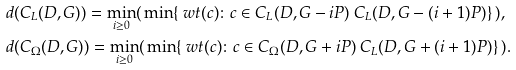Convert formula to latex. <formula><loc_0><loc_0><loc_500><loc_500>& d ( C _ { L } ( D , G ) ) = \min _ { i \geq 0 } ( \, \min \{ \ w t ( c ) \colon c \in C _ { L } ( D , G - i P ) \ C _ { L } ( D , G - ( i + 1 ) P ) \} \, ) , \\ & d ( C _ { \Omega } ( D , G ) ) = \min _ { i \geq 0 } ( \, \min \{ \ w t ( c ) \colon c \in C _ { \Omega } ( D , G + i P ) \ C _ { L } ( D , G + ( i + 1 ) P ) \} \, ) .</formula> 